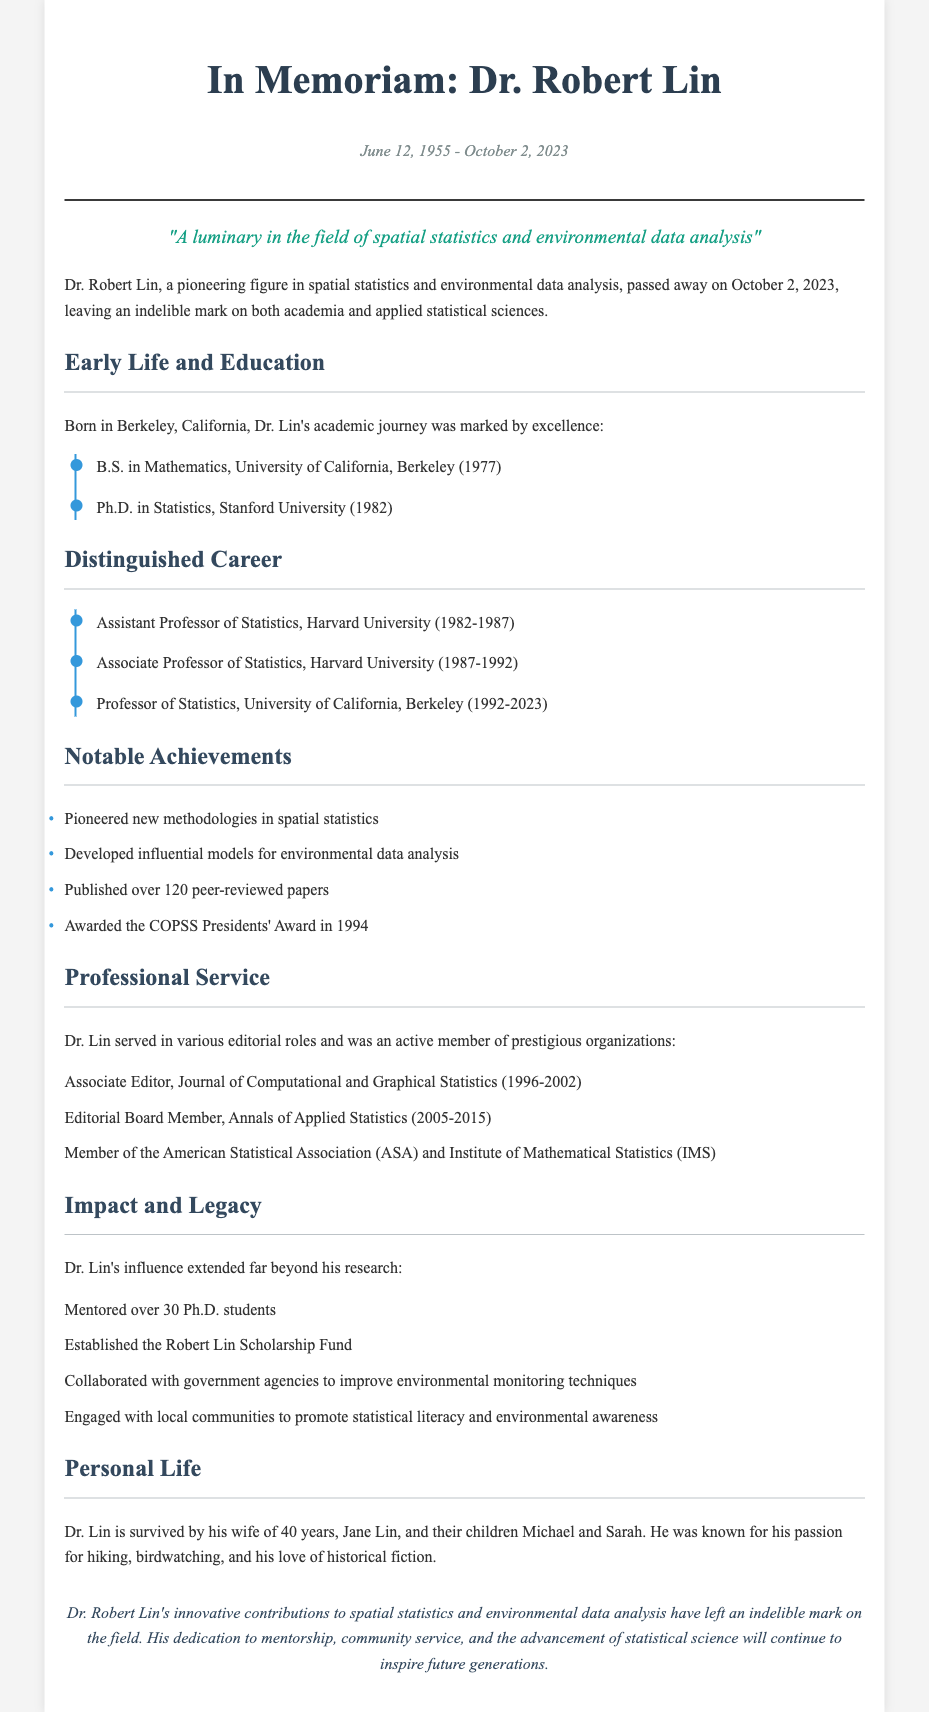What is Dr. Lin's date of birth? Dr. Lin was born on June 12, 1955, as stated in the dates section of the obituary.
Answer: June 12, 1955 What degree did Dr. Lin receive from Stanford University? The document mentions that Dr. Lin earned a Ph.D. in Statistics from Stanford University in 1982.
Answer: Ph.D. in Statistics How many peer-reviewed papers did Dr. Lin publish? According to the notable achievements section, Dr. Lin published over 120 peer-reviewed papers.
Answer: Over 120 What award did Dr. Lin receive in 1994? The obituary states that Dr. Lin was awarded the COPSS Presidents' Award in 1994.
Answer: COPSS Presidents' Award How long did Dr. Lin serve at the University of California, Berkeley? The document specifies that Dr. Lin was a Professor of Statistics at the University of California, Berkeley from 1992 to 2023, which amounts to 31 years.
Answer: 31 years What was one of Dr. Lin's contributions to environmental monitoring? The document states that he collaborated with government agencies to improve environmental monitoring techniques, indicating his influence on this practice.
Answer: Improved environmental monitoring techniques How many Ph.D. students did Dr. Lin mentor? The impact and legacy section mentions that Dr. Lin mentored over 30 Ph.D. students.
Answer: Over 30 In how many years did Dr. Lin hold his positions at Harvard University? The timeline shows that Dr. Lin worked at Harvard University from 1982 to 1992, totaling 10 years.
Answer: 10 years What personal hobbies did Dr. Lin enjoy? The personal life section mentions his passion for hiking and birdwatching.
Answer: Hiking and birdwatching 